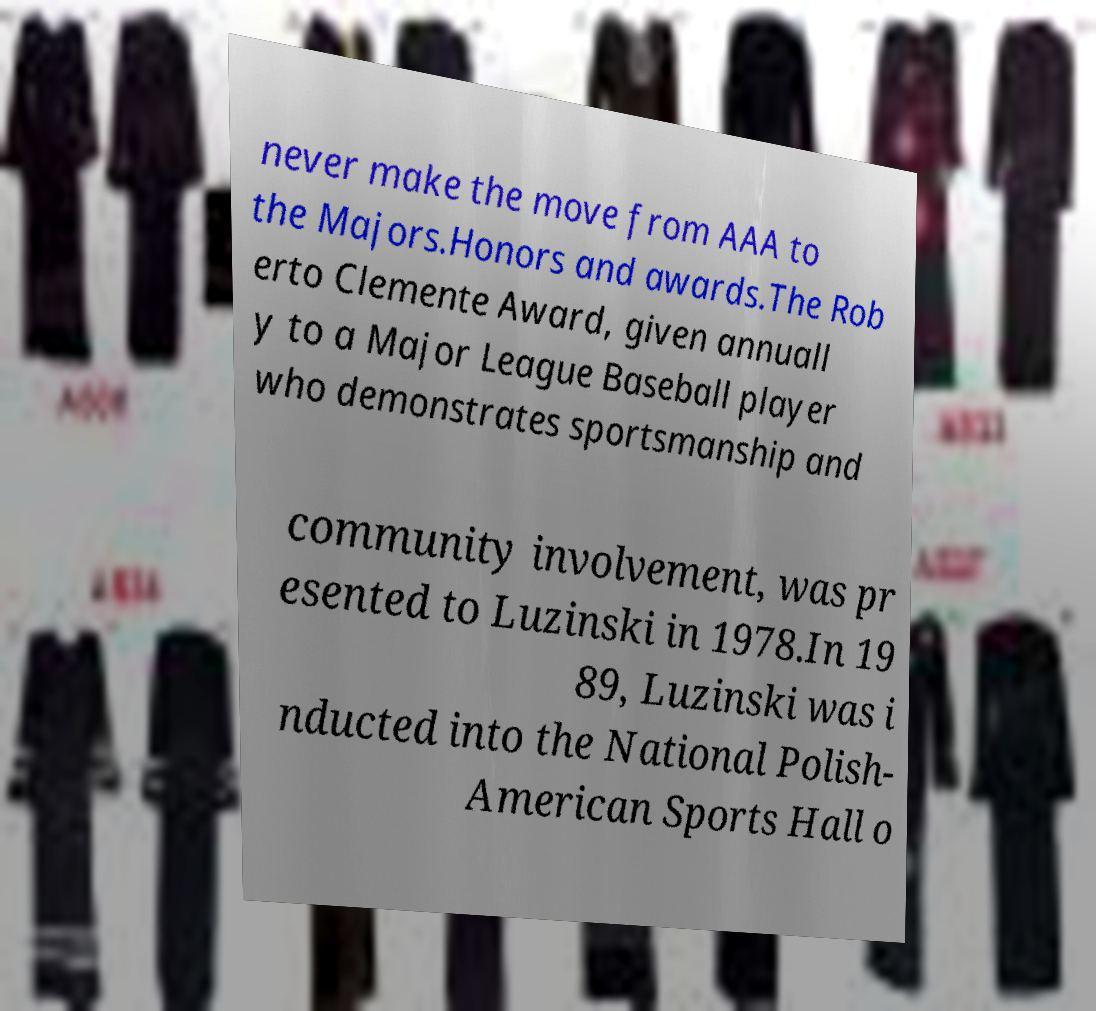Can you accurately transcribe the text from the provided image for me? never make the move from AAA to the Majors.Honors and awards.The Rob erto Clemente Award, given annuall y to a Major League Baseball player who demonstrates sportsmanship and community involvement, was pr esented to Luzinski in 1978.In 19 89, Luzinski was i nducted into the National Polish- American Sports Hall o 